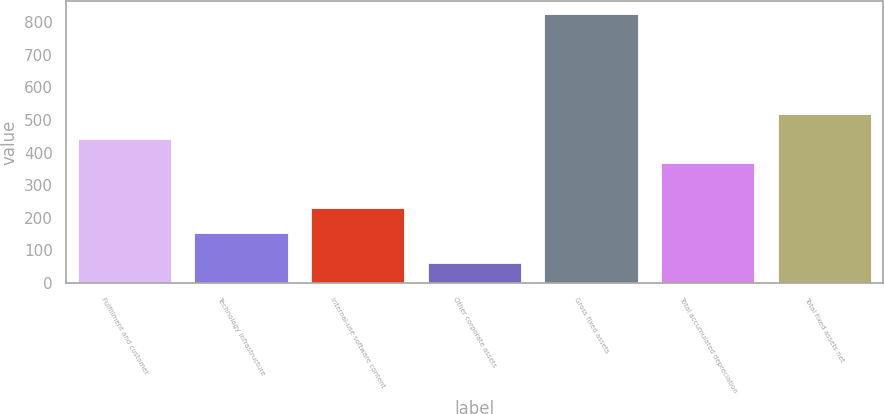<chart> <loc_0><loc_0><loc_500><loc_500><bar_chart><fcel>Fulfillment and customer<fcel>Technology infrastructure<fcel>Internal-use software content<fcel>Other corporate assets<fcel>Gross fixed assets<fcel>Total accumulated depreciation<fcel>Total fixed assets net<nl><fcel>443.2<fcel>153<fcel>230<fcel>62<fcel>824<fcel>367<fcel>519.4<nl></chart> 